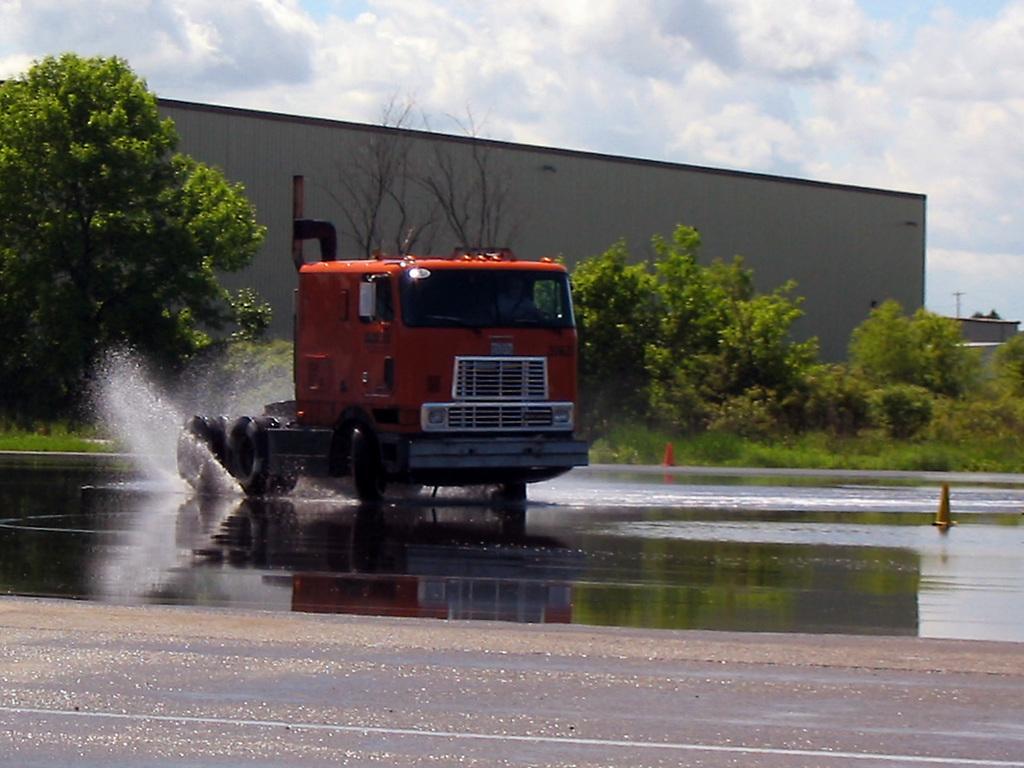Could you give a brief overview of what you see in this image? In this image we can see a vehicle on the road. There is water and we can see traffic cones. In the background there are trees and sky. We can see a shed. There is a pole. 